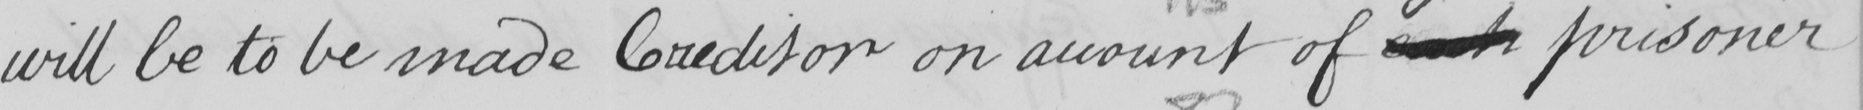What does this handwritten line say? will be to be made Creditor on account of each prisoner 